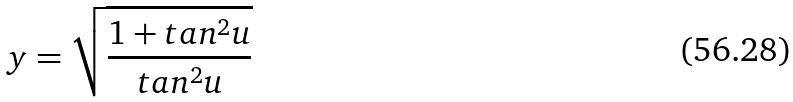<formula> <loc_0><loc_0><loc_500><loc_500>y = \sqrt { \frac { 1 + t a n ^ { 2 } u } { t a n ^ { 2 } u } }</formula> 